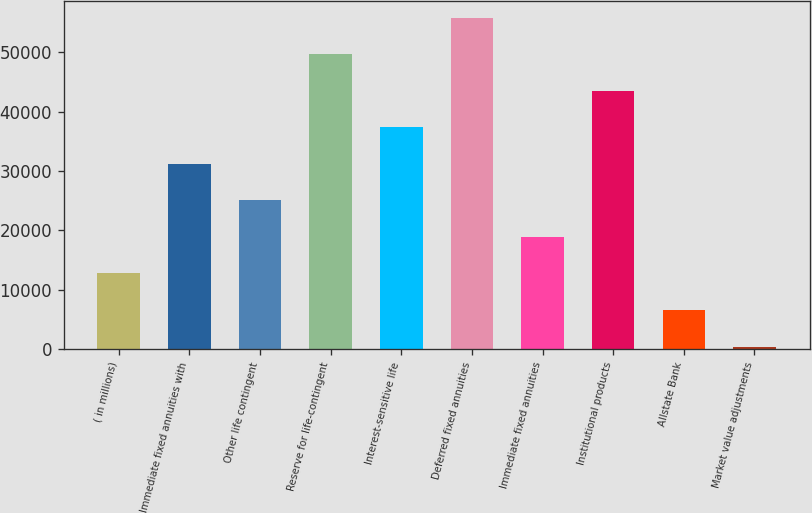Convert chart to OTSL. <chart><loc_0><loc_0><loc_500><loc_500><bar_chart><fcel>( in millions)<fcel>Immediate fixed annuities with<fcel>Other life contingent<fcel>Reserve for life-contingent<fcel>Interest-sensitive life<fcel>Deferred fixed annuities<fcel>Immediate fixed annuities<fcel>Institutional products<fcel>Allstate Bank<fcel>Market value adjustments<nl><fcel>12746.2<fcel>31228<fcel>25067.4<fcel>49709.8<fcel>37388.6<fcel>55870.4<fcel>18906.8<fcel>43549.2<fcel>6585.6<fcel>425<nl></chart> 